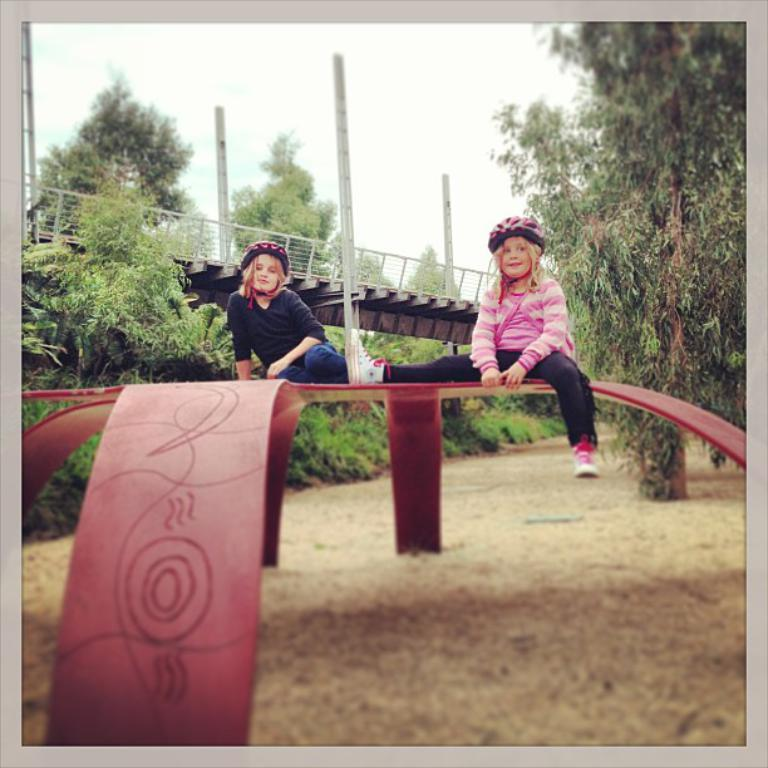How many children are in the image? There are two children in the image. What can be seen in the background of the image? In the background of the image, there are plants, trees, poles, a bridge, and the sky. Can you describe the natural elements visible in the image? The natural elements visible in the image include plants, trees, and the sky. What type of lock is used to secure the bridge in the image? There is no lock visible on the bridge in the image. 